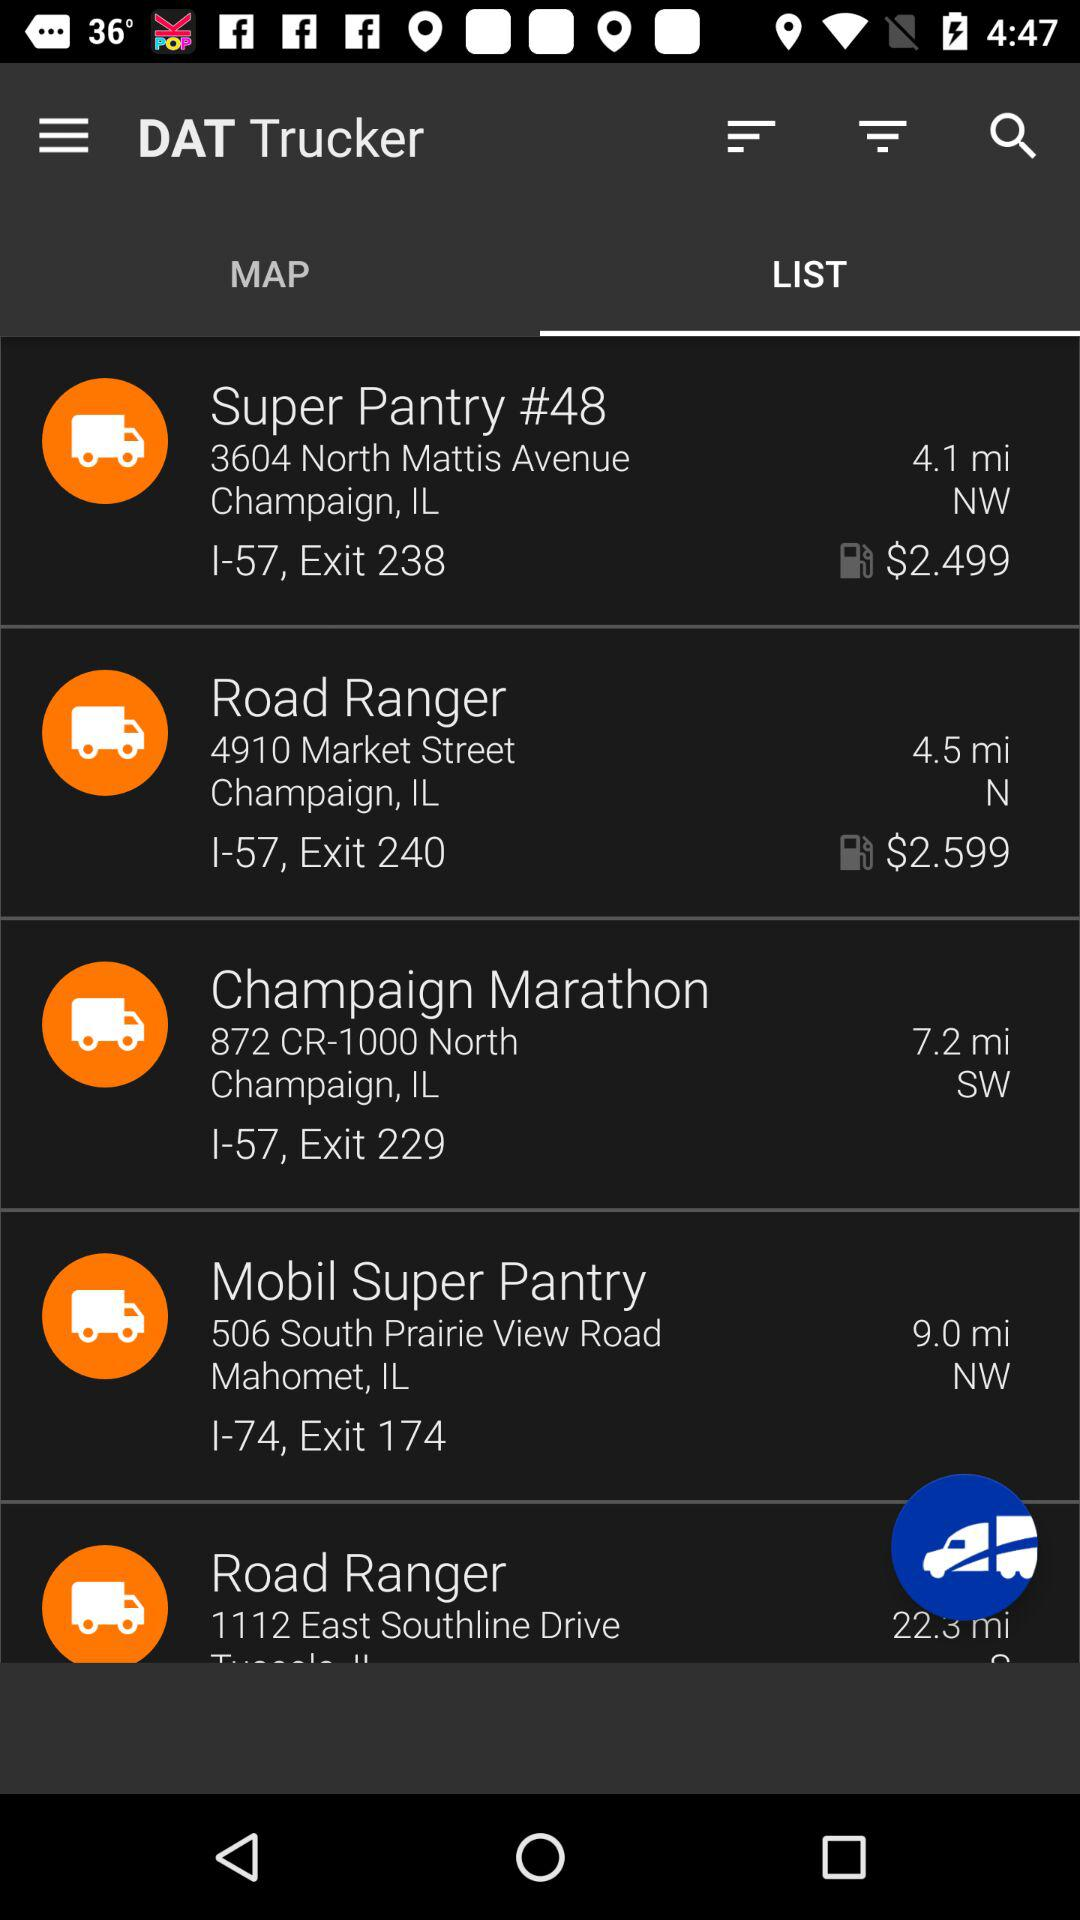What direction is shown for the Mobil Super Pantry? The direction shown is "NW". 